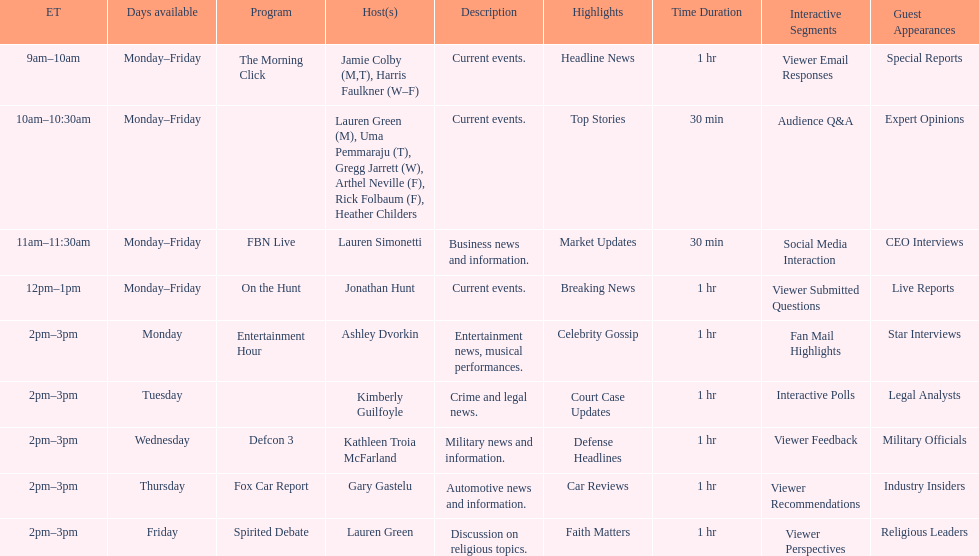How long does the show defcon 3 last? 1 hour. 